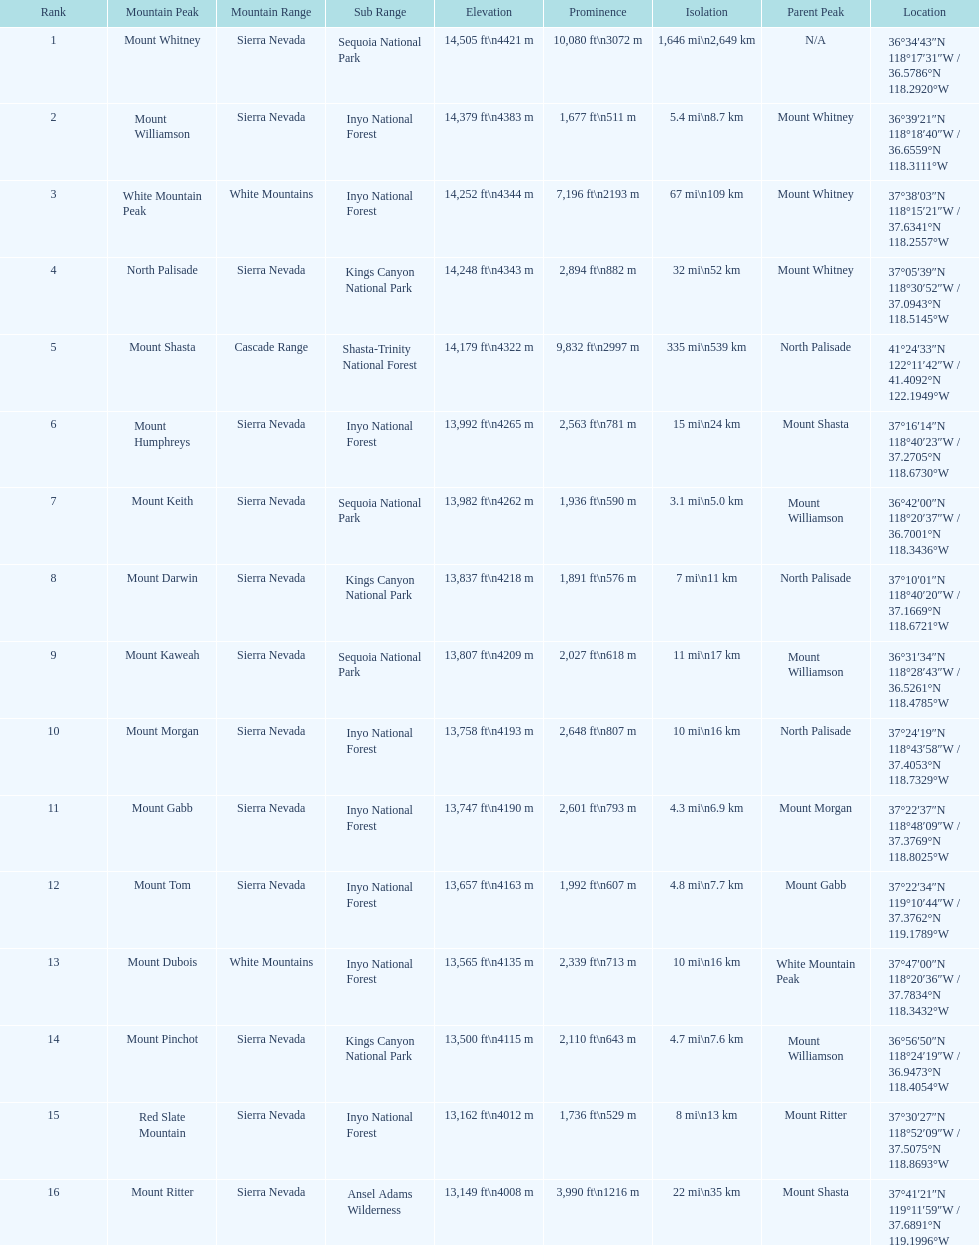Which mountain peak has the least isolation? Mount Keith. 